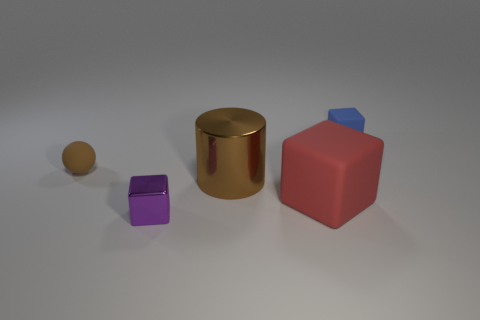What material is the small purple object that is the same shape as the large red rubber object?
Your answer should be compact. Metal. There is a tiny rubber thing to the left of the tiny blue thing; is its color the same as the cylinder?
Provide a short and direct response. Yes. Are the tiny purple block and the thing that is left of the purple cube made of the same material?
Your answer should be compact. No. What is the shape of the tiny object that is in front of the big red cube?
Your answer should be compact. Cube. What number of other objects are there of the same material as the brown ball?
Your answer should be very brief. 2. The red cube has what size?
Provide a succinct answer. Large. How many other objects are the same color as the big cylinder?
Your response must be concise. 1. What is the color of the block that is on the right side of the small metal object and left of the blue block?
Provide a succinct answer. Red. How many large cyan matte things are there?
Offer a terse response. 0. Does the large cylinder have the same material as the small brown sphere?
Keep it short and to the point. No. 